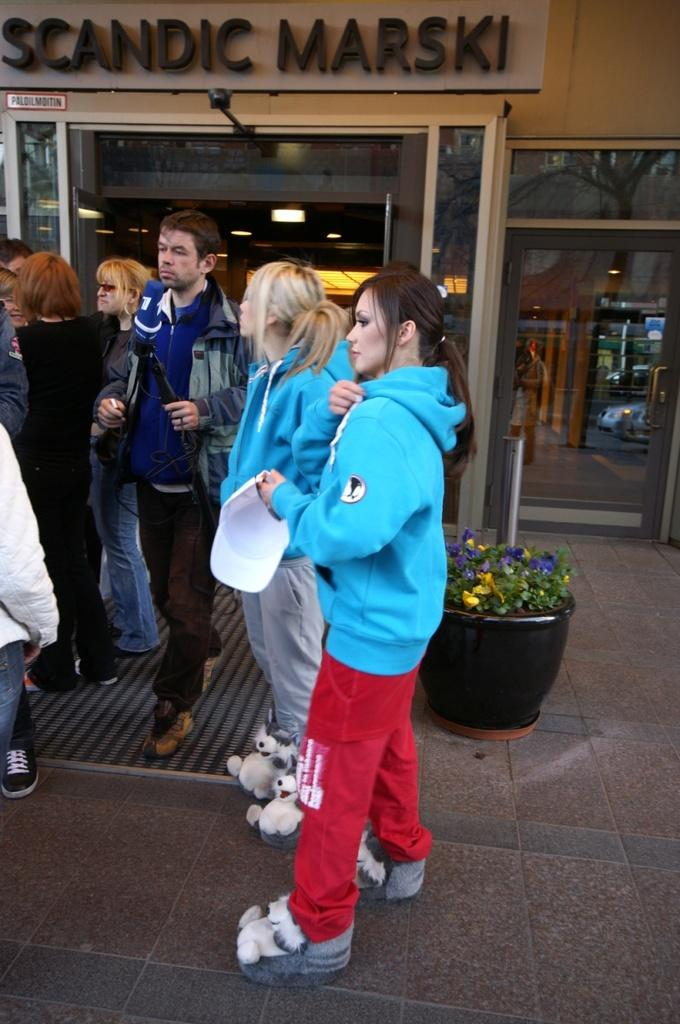What are the people in the image doing? The people in the image are standing in the center. What can be seen in the background of the image? There is a store in the background of the image. What type of object is present in the image? There is a flower pot in the image. What is visible at the bottom of the image? The floor is visible at the bottom of the image. Where is the throne located in the image? There is no throne present in the image. What type of pancake is being served to the boys in the image? There are no boys or pancakes present in the image. 